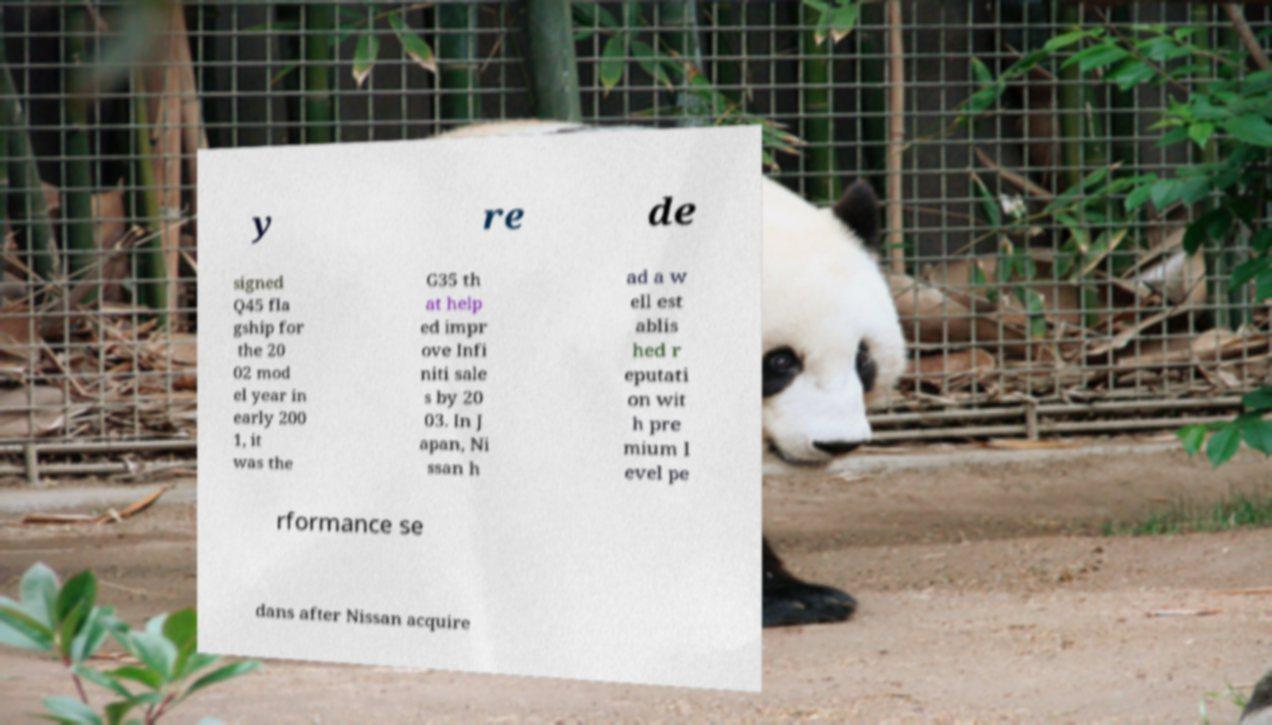Please identify and transcribe the text found in this image. y re de signed Q45 fla gship for the 20 02 mod el year in early 200 1, it was the G35 th at help ed impr ove Infi niti sale s by 20 03. In J apan, Ni ssan h ad a w ell est ablis hed r eputati on wit h pre mium l evel pe rformance se dans after Nissan acquire 